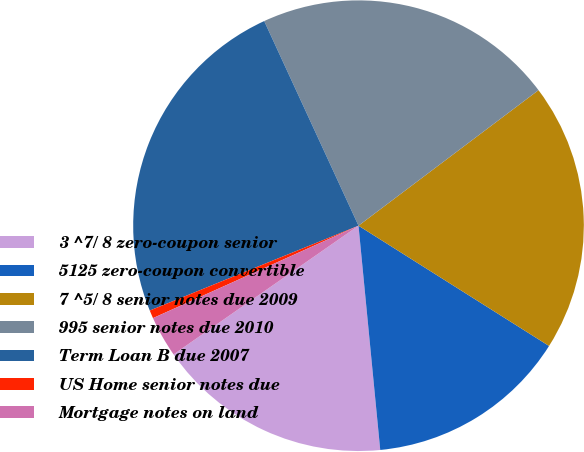Convert chart to OTSL. <chart><loc_0><loc_0><loc_500><loc_500><pie_chart><fcel>3 ^7/ 8 zero-coupon senior<fcel>5125 zero-coupon convertible<fcel>7 ^5/ 8 senior notes due 2009<fcel>995 senior notes due 2010<fcel>Term Loan B due 2007<fcel>US Home senior notes due<fcel>Mortgage notes on land<nl><fcel>16.86%<fcel>14.5%<fcel>19.23%<fcel>21.6%<fcel>24.27%<fcel>0.58%<fcel>2.95%<nl></chart> 